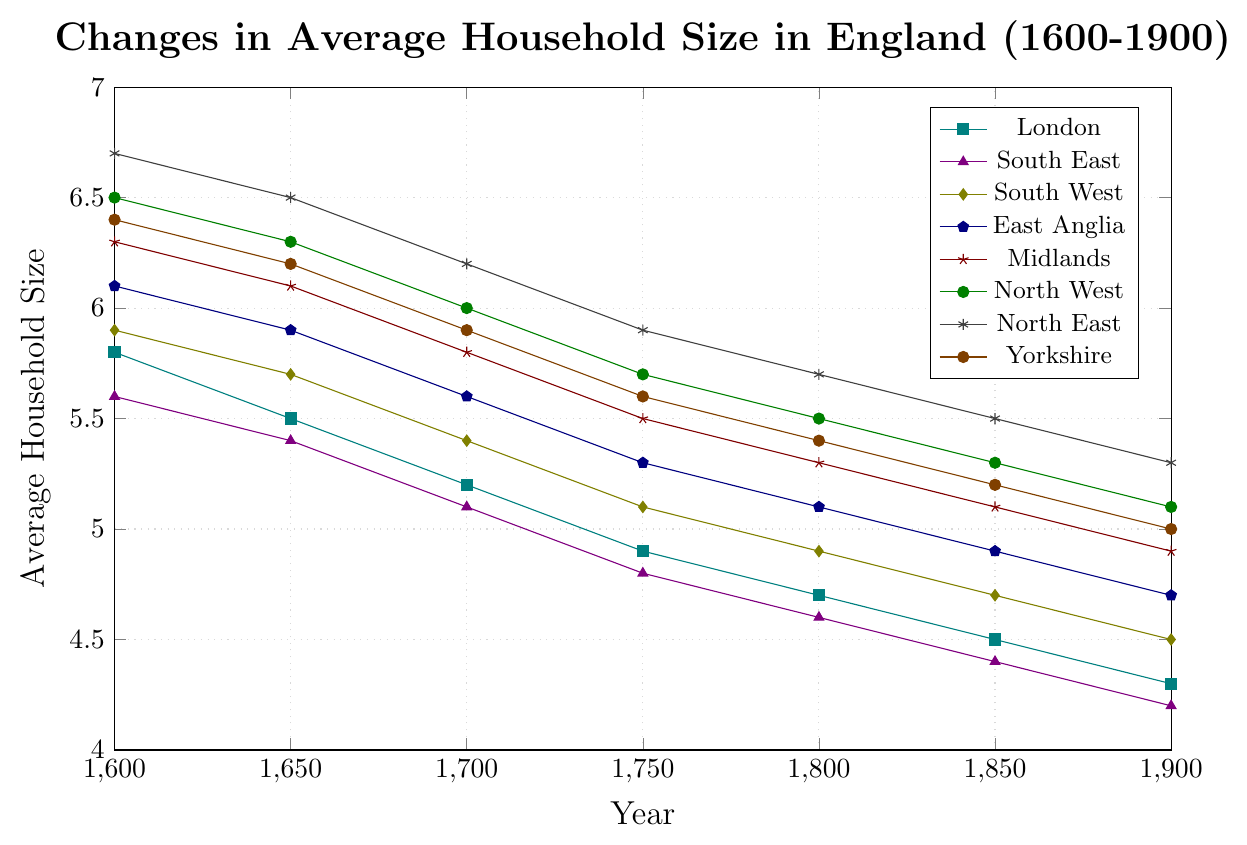Which region had the highest average household size in 1600? From the plot, the highest line at 1600 corresponds to the North East region with a value of 6.7.
Answer: North East Which region shows the smallest decrease in average household size from 1600 to 1900? By comparing the start and end values of each region, London had the smallest decrease, from 5.8 to 4.3, which is a decrease of 1.5.
Answer: London Between 1700 and 1850, how much did the average household size in East Anglia decrease? At 1700, East Anglia's average was 5.6, and at 1850 it was 4.9. The decrease is calculated as 5.6 - 4.9 = 0.7.
Answer: 0.7 Which regions had an average household size greater than 5 in 1750? From the plot at 1750, the regions with an average household size greater than 5 are North East, North West, Yorkshire, Midlands, and East Anglia.
Answer: North East, North West, Yorkshire, Midlands, East Anglia By how much did the average household size in the North West region change between 1650 and 1700? The average household size of the North West was 6.3 in 1650 and 6.0 in 1700. The change is 6.3 - 6.0 = 0.3.
Answer: 0.3 What is the trend in average household size for London between 1600 and 1900, and is it consistent? The trend for London shows a consistent decrease at every interval from 5.8 in 1600 to 4.3 in 1900.
Answer: Decreasing, consistent Which regions' average household sizes converged most closely by 1900? By 1900, London and South East had average household sizes of 4.3 and 4.2 respectively, showing very close values.
Answer: London, South East What was the approximate average household size in Yorkshire in 1800? From the data at 1800, Yorkshire had an average household size of 5.4.
Answer: 5.4 Which region had the largest average household size in 1750 and what was the value? In 1750, the North East region had the largest average household size with a value of 5.9.
Answer: North East, 5.9 